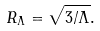Convert formula to latex. <formula><loc_0><loc_0><loc_500><loc_500>R _ { \Lambda } = \sqrt { 3 / \Lambda } .</formula> 